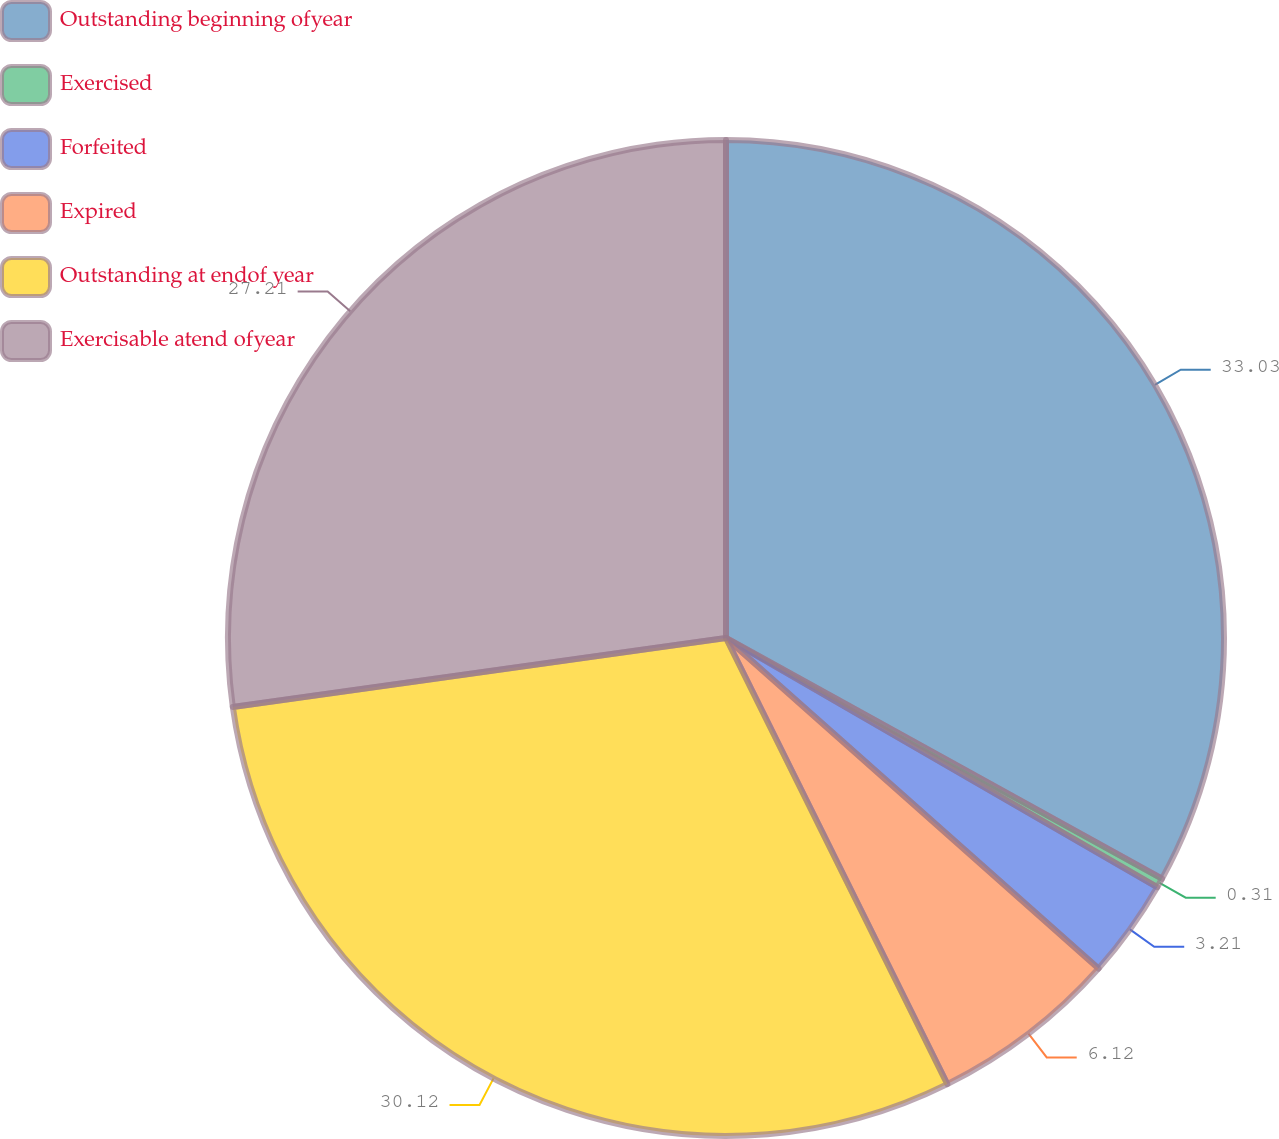<chart> <loc_0><loc_0><loc_500><loc_500><pie_chart><fcel>Outstanding beginning ofyear<fcel>Exercised<fcel>Forfeited<fcel>Expired<fcel>Outstanding at endof year<fcel>Exercisable atend ofyear<nl><fcel>33.03%<fcel>0.31%<fcel>3.21%<fcel>6.12%<fcel>30.12%<fcel>27.21%<nl></chart> 